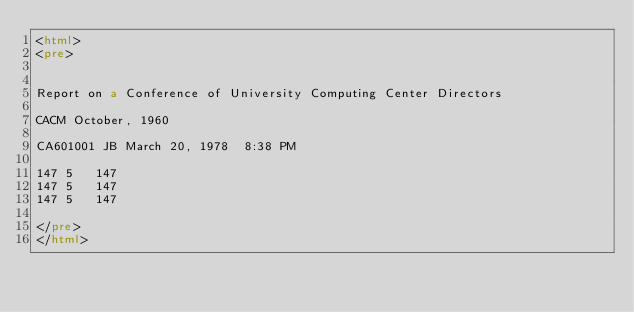<code> <loc_0><loc_0><loc_500><loc_500><_HTML_><html>
<pre>


Report on a Conference of University Computing Center Directors

CACM October, 1960

CA601001 JB March 20, 1978  8:38 PM

147	5	147
147	5	147
147	5	147

</pre>
</html>
</code> 